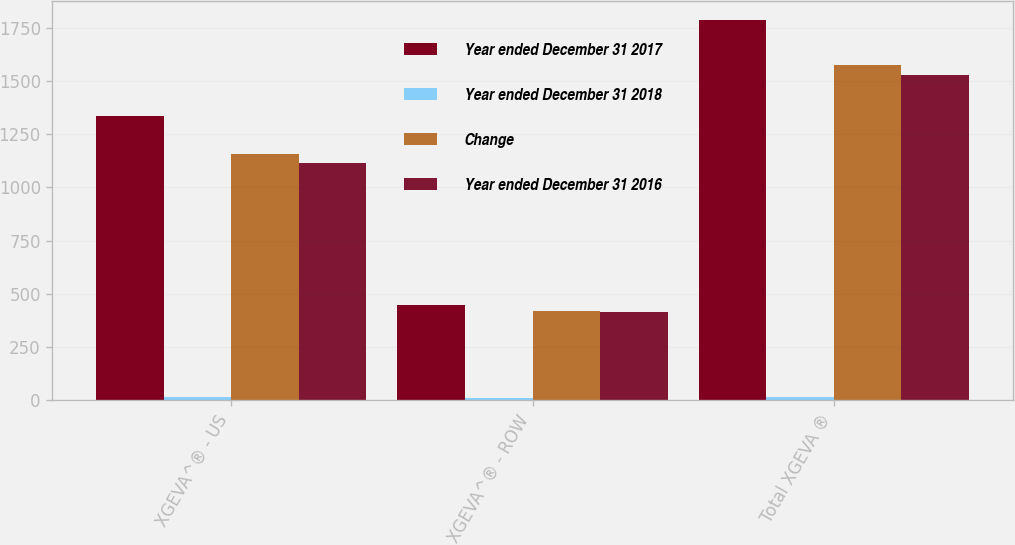Convert chart. <chart><loc_0><loc_0><loc_500><loc_500><stacked_bar_chart><ecel><fcel>XGEVA^® - US<fcel>XGEVA^® - ROW<fcel>Total XGEVA ®<nl><fcel>Year ended December 31 2017<fcel>1338<fcel>448<fcel>1786<nl><fcel>Year ended December 31 2018<fcel>16<fcel>7<fcel>13<nl><fcel>Change<fcel>1157<fcel>418<fcel>1575<nl><fcel>Year ended December 31 2016<fcel>1115<fcel>414<fcel>1529<nl></chart> 